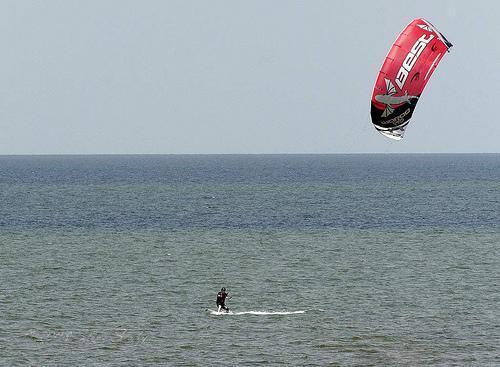How many people are in the water?
Give a very brief answer. 1. 